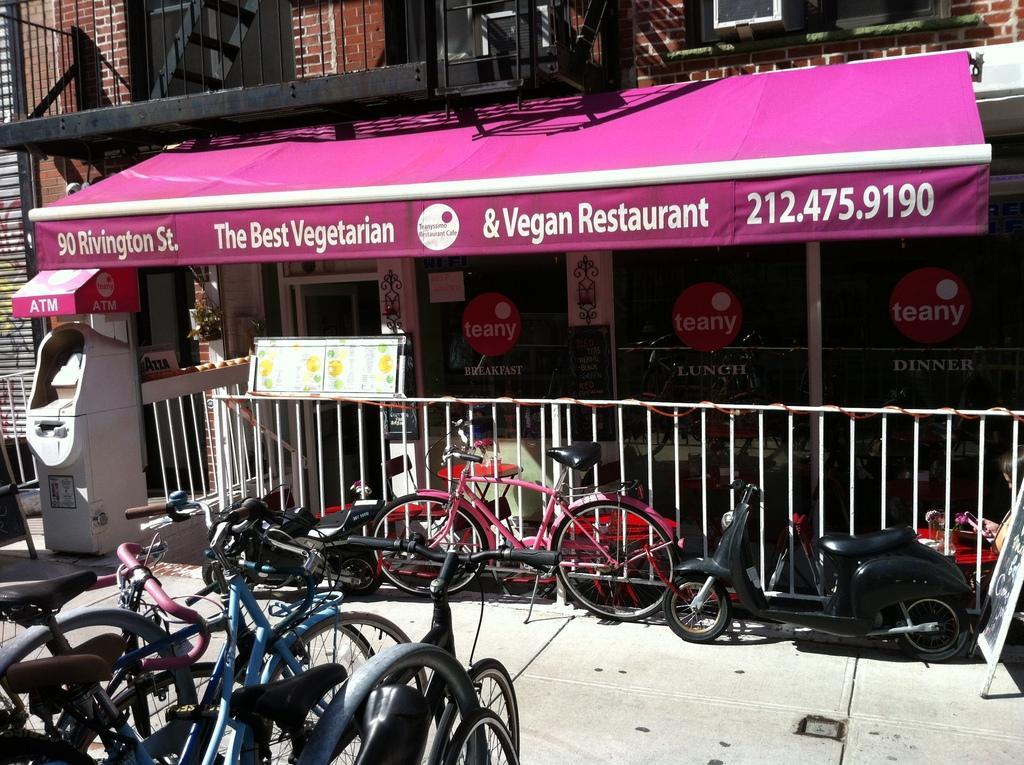Describe this image in one or two sentences. In this picture we can see vehicles, railings, machine and boards. We can see building, posters on glass, store and objects. 